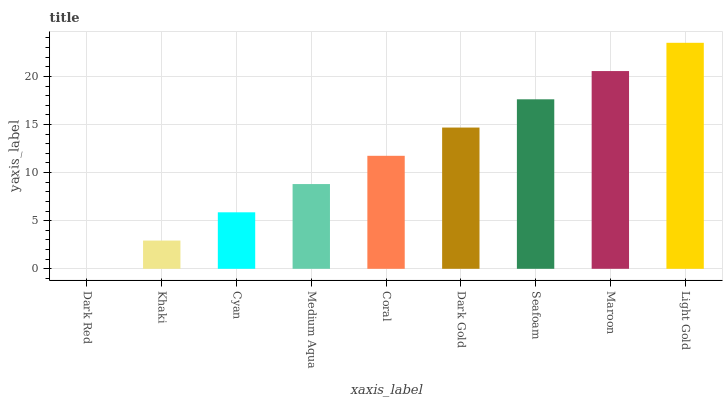Is Dark Red the minimum?
Answer yes or no. Yes. Is Light Gold the maximum?
Answer yes or no. Yes. Is Khaki the minimum?
Answer yes or no. No. Is Khaki the maximum?
Answer yes or no. No. Is Khaki greater than Dark Red?
Answer yes or no. Yes. Is Dark Red less than Khaki?
Answer yes or no. Yes. Is Dark Red greater than Khaki?
Answer yes or no. No. Is Khaki less than Dark Red?
Answer yes or no. No. Is Coral the high median?
Answer yes or no. Yes. Is Coral the low median?
Answer yes or no. Yes. Is Medium Aqua the high median?
Answer yes or no. No. Is Medium Aqua the low median?
Answer yes or no. No. 